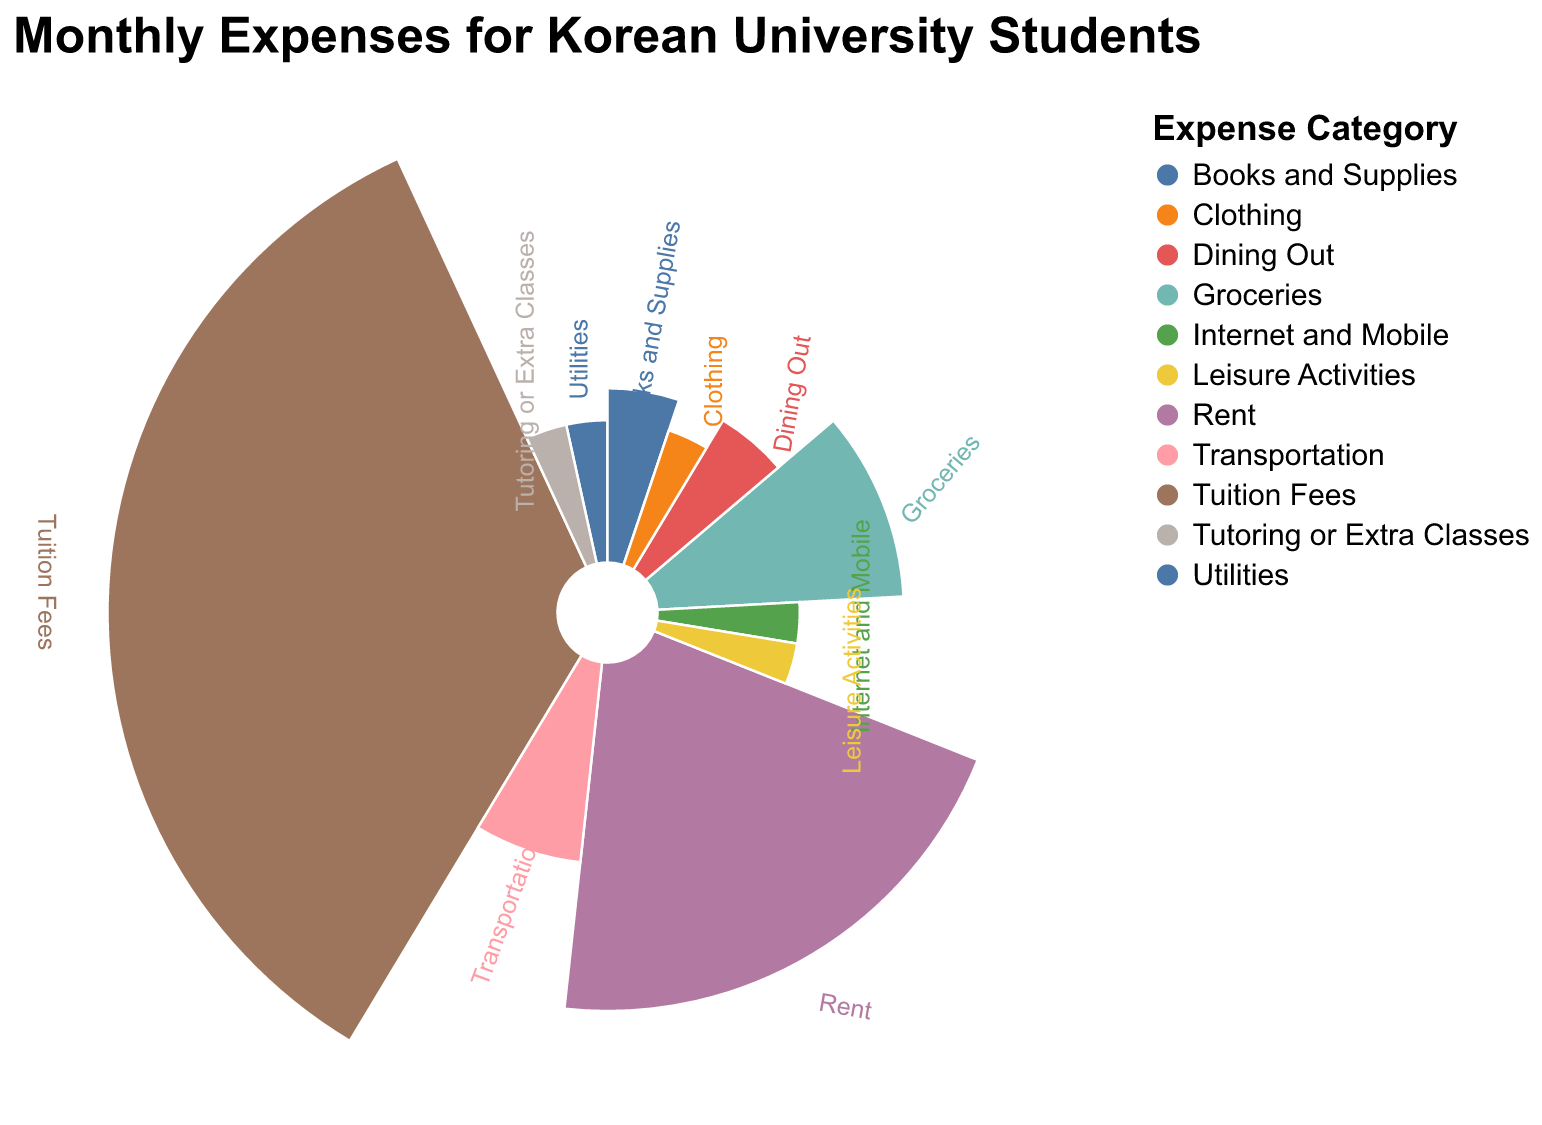What is the title of the figure? The title of the figure is located at the top and indicates the main topic of the chart. It reads "Monthly Expenses for Korean University Students".
Answer: Monthly Expenses for Korean University Students Which expense category has the highest amount? The largest section of the polar chart will correspond to the category with the highest amount. This is visually clear by the size and central placement of the "Tuition Fees" label and arc.
Answer: Tuition Fees How many expense categories have amounts equal to 50,000 KRW? Identify the arcs that are labeled with amounts and find the ones with the amount "50,000 KRW". There are five such categories: Utilities, Internet and Mobile, Leisure Activities, Clothing, and Tutoring or Extra Classes.
Answer: Five What is the total amount allocated to Rent and Groceries? Look at the chart to find the values for Rent (300,000 KRW) and Groceries (150,000 KRW). Adding these amounts together: 300,000 + 150,000 = 450,000 KRW.
Answer: 450,000 KRW Which expense categories have equal amounts of 75,000 KRW? Locate the labels with the indicated amounts on the polar chart. Identify that "Books and Supplies" and "Dining Out" have equal amounts of 75,000 KRW.
Answer: Books and Supplies and Dining Out How does the amount for Transportation compare to the amount for Utilities? Compare the sections labeled "Transportation" and "Utilities" on the chart. Transportation is 100,000 KRW, while Utilities is 50,000 KRW. So, Transportation is greater.
Answer: Transportation is greater What is the average amount allocated to Dining Out, Leisure Activities, and Clothing? Add the amounts of Dining Out (75,000 KRW), Leisure Activities (50,000 KRW), and Clothing (50,000 KRW) and divide by 3: (75,000 + 50,000 + 50,000) / 3 = 58,333.33 KRW.
Answer: 58,333.33 KRW Which section of the chart is the smallest? The smallest section will represent the smallest amount, which can be visually identified. Each of the following categories has the same smallest amount of 50,000 KRW: Utilities, Internet and Mobile, Leisure Activities, Clothing, and Tutoring or Extra Classes.
Answer: Utilities, Internet and Mobile, Leisure Activities, Clothing, and Tutoring or Extra Classes What is the combined total for Internet and Mobile, Books and Supplies, and Dining Out? Summing the amounts for Internet and Mobile (50,000 KRW), Books and Supplies (75,000 KRW), and Dining Out (75,000 KRW): 50,000 + 75,000 + 75,000 = 200,000 KRW.
Answer: 200,000 KRW 